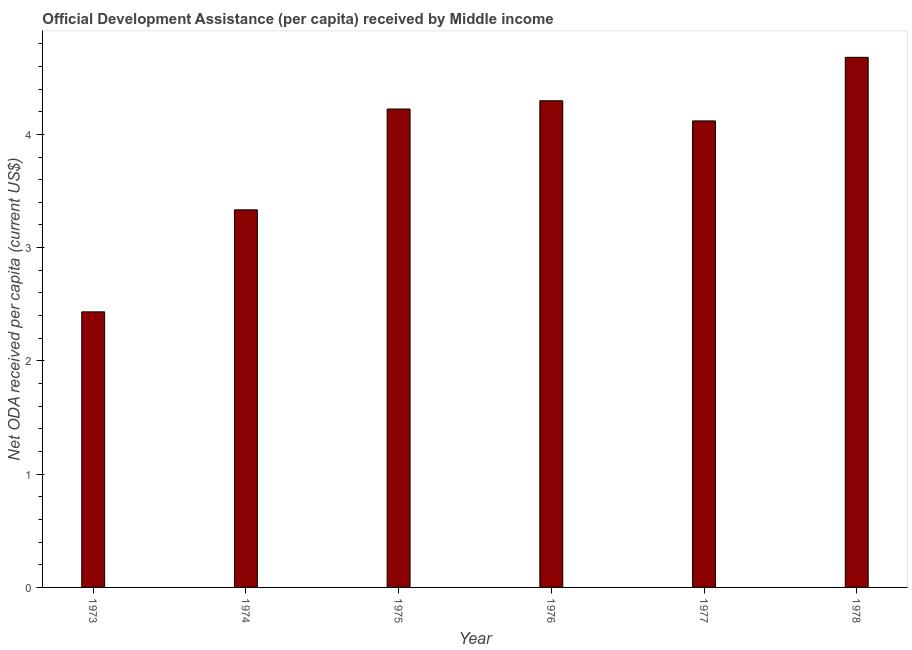Does the graph contain any zero values?
Ensure brevity in your answer.  No. What is the title of the graph?
Ensure brevity in your answer.  Official Development Assistance (per capita) received by Middle income. What is the label or title of the Y-axis?
Your answer should be compact. Net ODA received per capita (current US$). What is the net oda received per capita in 1973?
Your response must be concise. 2.43. Across all years, what is the maximum net oda received per capita?
Offer a terse response. 4.68. Across all years, what is the minimum net oda received per capita?
Provide a short and direct response. 2.43. In which year was the net oda received per capita maximum?
Your response must be concise. 1978. What is the sum of the net oda received per capita?
Ensure brevity in your answer.  23.09. What is the difference between the net oda received per capita in 1977 and 1978?
Your answer should be very brief. -0.56. What is the average net oda received per capita per year?
Make the answer very short. 3.85. What is the median net oda received per capita?
Your answer should be compact. 4.17. In how many years, is the net oda received per capita greater than 0.2 US$?
Your response must be concise. 6. What is the ratio of the net oda received per capita in 1973 to that in 1975?
Make the answer very short. 0.58. What is the difference between the highest and the second highest net oda received per capita?
Give a very brief answer. 0.38. Is the sum of the net oda received per capita in 1975 and 1978 greater than the maximum net oda received per capita across all years?
Ensure brevity in your answer.  Yes. What is the difference between the highest and the lowest net oda received per capita?
Offer a very short reply. 2.25. How many bars are there?
Offer a terse response. 6. How many years are there in the graph?
Keep it short and to the point. 6. What is the difference between two consecutive major ticks on the Y-axis?
Offer a very short reply. 1. What is the Net ODA received per capita (current US$) of 1973?
Offer a very short reply. 2.43. What is the Net ODA received per capita (current US$) in 1974?
Keep it short and to the point. 3.33. What is the Net ODA received per capita (current US$) of 1975?
Make the answer very short. 4.22. What is the Net ODA received per capita (current US$) in 1976?
Give a very brief answer. 4.3. What is the Net ODA received per capita (current US$) of 1977?
Your answer should be very brief. 4.12. What is the Net ODA received per capita (current US$) in 1978?
Offer a terse response. 4.68. What is the difference between the Net ODA received per capita (current US$) in 1973 and 1974?
Offer a very short reply. -0.9. What is the difference between the Net ODA received per capita (current US$) in 1973 and 1975?
Make the answer very short. -1.79. What is the difference between the Net ODA received per capita (current US$) in 1973 and 1976?
Provide a short and direct response. -1.86. What is the difference between the Net ODA received per capita (current US$) in 1973 and 1977?
Offer a terse response. -1.69. What is the difference between the Net ODA received per capita (current US$) in 1973 and 1978?
Offer a terse response. -2.25. What is the difference between the Net ODA received per capita (current US$) in 1974 and 1975?
Offer a terse response. -0.89. What is the difference between the Net ODA received per capita (current US$) in 1974 and 1976?
Offer a very short reply. -0.96. What is the difference between the Net ODA received per capita (current US$) in 1974 and 1977?
Your response must be concise. -0.79. What is the difference between the Net ODA received per capita (current US$) in 1974 and 1978?
Your answer should be compact. -1.35. What is the difference between the Net ODA received per capita (current US$) in 1975 and 1976?
Provide a succinct answer. -0.07. What is the difference between the Net ODA received per capita (current US$) in 1975 and 1977?
Provide a succinct answer. 0.11. What is the difference between the Net ODA received per capita (current US$) in 1975 and 1978?
Offer a very short reply. -0.46. What is the difference between the Net ODA received per capita (current US$) in 1976 and 1977?
Give a very brief answer. 0.18. What is the difference between the Net ODA received per capita (current US$) in 1976 and 1978?
Keep it short and to the point. -0.38. What is the difference between the Net ODA received per capita (current US$) in 1977 and 1978?
Your answer should be compact. -0.56. What is the ratio of the Net ODA received per capita (current US$) in 1973 to that in 1974?
Ensure brevity in your answer.  0.73. What is the ratio of the Net ODA received per capita (current US$) in 1973 to that in 1975?
Your answer should be compact. 0.58. What is the ratio of the Net ODA received per capita (current US$) in 1973 to that in 1976?
Offer a very short reply. 0.57. What is the ratio of the Net ODA received per capita (current US$) in 1973 to that in 1977?
Your answer should be compact. 0.59. What is the ratio of the Net ODA received per capita (current US$) in 1973 to that in 1978?
Your answer should be compact. 0.52. What is the ratio of the Net ODA received per capita (current US$) in 1974 to that in 1975?
Offer a very short reply. 0.79. What is the ratio of the Net ODA received per capita (current US$) in 1974 to that in 1976?
Offer a very short reply. 0.78. What is the ratio of the Net ODA received per capita (current US$) in 1974 to that in 1977?
Provide a short and direct response. 0.81. What is the ratio of the Net ODA received per capita (current US$) in 1974 to that in 1978?
Offer a terse response. 0.71. What is the ratio of the Net ODA received per capita (current US$) in 1975 to that in 1976?
Your answer should be very brief. 0.98. What is the ratio of the Net ODA received per capita (current US$) in 1975 to that in 1977?
Your response must be concise. 1.02. What is the ratio of the Net ODA received per capita (current US$) in 1975 to that in 1978?
Give a very brief answer. 0.9. What is the ratio of the Net ODA received per capita (current US$) in 1976 to that in 1977?
Your answer should be very brief. 1.04. What is the ratio of the Net ODA received per capita (current US$) in 1976 to that in 1978?
Offer a very short reply. 0.92. What is the ratio of the Net ODA received per capita (current US$) in 1977 to that in 1978?
Your answer should be very brief. 0.88. 